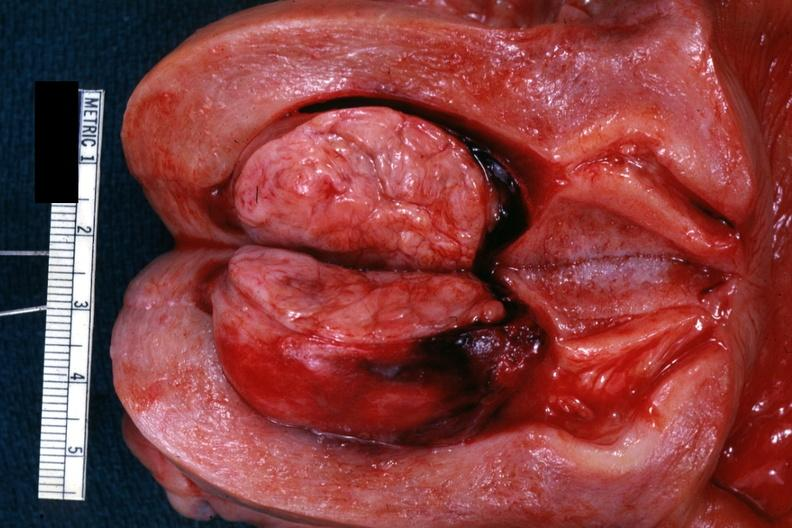what is present?
Answer the question using a single word or phrase. Leiomyoma 